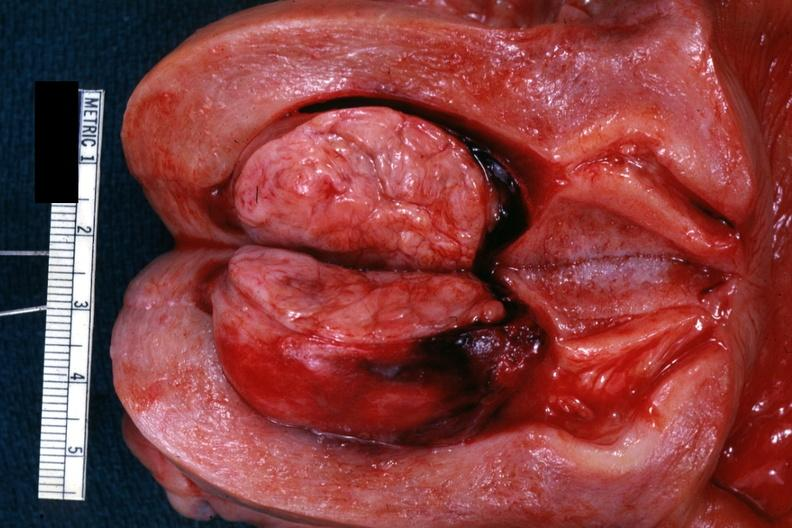what is present?
Answer the question using a single word or phrase. Leiomyoma 